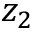<formula> <loc_0><loc_0><loc_500><loc_500>z _ { 2 }</formula> 